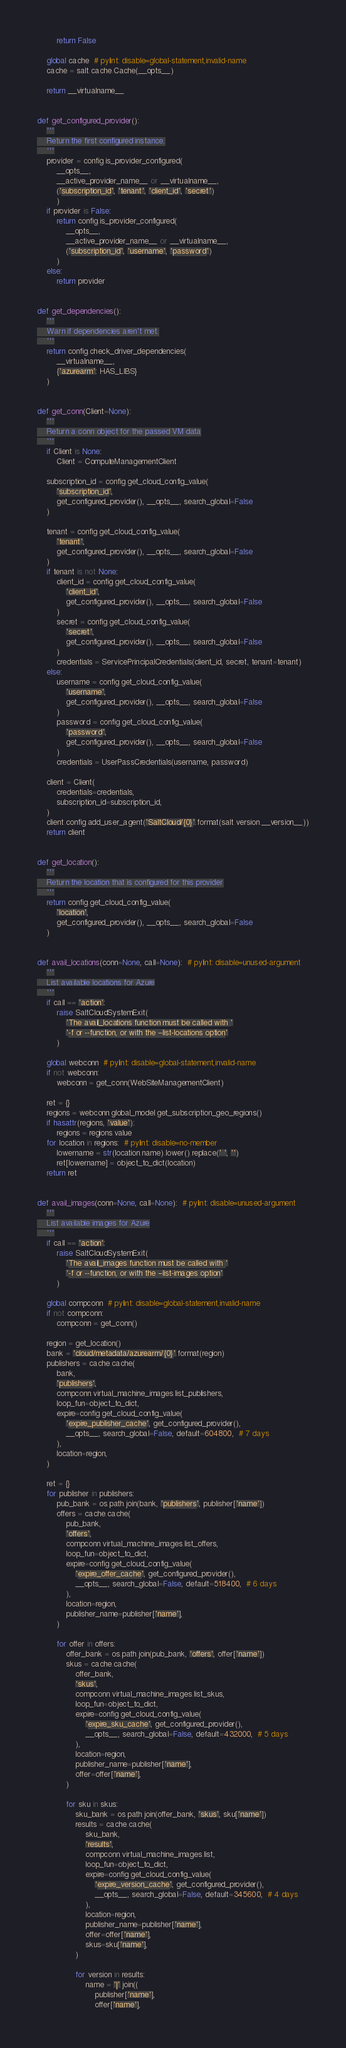Convert code to text. <code><loc_0><loc_0><loc_500><loc_500><_Python_>        return False

    global cache  # pylint: disable=global-statement,invalid-name
    cache = salt.cache.Cache(__opts__)

    return __virtualname__


def get_configured_provider():
    '''
    Return the first configured instance.
    '''
    provider = config.is_provider_configured(
        __opts__,
        __active_provider_name__ or __virtualname__,
        ('subscription_id', 'tenant', 'client_id', 'secret')
        )
    if provider is False:
        return config.is_provider_configured(
            __opts__,
            __active_provider_name__ or __virtualname__,
            ('subscription_id', 'username', 'password')
        )
    else:
        return provider


def get_dependencies():
    '''
    Warn if dependencies aren't met.
    '''
    return config.check_driver_dependencies(
        __virtualname__,
        {'azurearm': HAS_LIBS}
    )


def get_conn(Client=None):
    '''
    Return a conn object for the passed VM data
    '''
    if Client is None:
        Client = ComputeManagementClient

    subscription_id = config.get_cloud_config_value(
        'subscription_id',
        get_configured_provider(), __opts__, search_global=False
    )

    tenant = config.get_cloud_config_value(
        'tenant',
        get_configured_provider(), __opts__, search_global=False
    )
    if tenant is not None:
        client_id = config.get_cloud_config_value(
            'client_id',
            get_configured_provider(), __opts__, search_global=False
        )
        secret = config.get_cloud_config_value(
            'secret',
            get_configured_provider(), __opts__, search_global=False
        )
        credentials = ServicePrincipalCredentials(client_id, secret, tenant=tenant)
    else:
        username = config.get_cloud_config_value(
            'username',
            get_configured_provider(), __opts__, search_global=False
        )
        password = config.get_cloud_config_value(
            'password',
            get_configured_provider(), __opts__, search_global=False
        )
        credentials = UserPassCredentials(username, password)

    client = Client(
        credentials=credentials,
        subscription_id=subscription_id,
    )
    client.config.add_user_agent('SaltCloud/{0}'.format(salt.version.__version__))
    return client


def get_location():
    '''
    Return the location that is configured for this provider
    '''
    return config.get_cloud_config_value(
        'location',
        get_configured_provider(), __opts__, search_global=False
    )


def avail_locations(conn=None, call=None):  # pylint: disable=unused-argument
    '''
    List available locations for Azure
    '''
    if call == 'action':
        raise SaltCloudSystemExit(
            'The avail_locations function must be called with '
            '-f or --function, or with the --list-locations option'
        )

    global webconn  # pylint: disable=global-statement,invalid-name
    if not webconn:
        webconn = get_conn(WebSiteManagementClient)

    ret = {}
    regions = webconn.global_model.get_subscription_geo_regions()
    if hasattr(regions, 'value'):
        regions = regions.value
    for location in regions:  # pylint: disable=no-member
        lowername = str(location.name).lower().replace(' ', '')
        ret[lowername] = object_to_dict(location)
    return ret


def avail_images(conn=None, call=None):  # pylint: disable=unused-argument
    '''
    List available images for Azure
    '''
    if call == 'action':
        raise SaltCloudSystemExit(
            'The avail_images function must be called with '
            '-f or --function, or with the --list-images option'
        )

    global compconn  # pylint: disable=global-statement,invalid-name
    if not compconn:
        compconn = get_conn()

    region = get_location()
    bank = 'cloud/metadata/azurearm/{0}'.format(region)
    publishers = cache.cache(
        bank,
        'publishers',
        compconn.virtual_machine_images.list_publishers,
        loop_fun=object_to_dict,
        expire=config.get_cloud_config_value(
            'expire_publisher_cache', get_configured_provider(),
            __opts__, search_global=False, default=604800,  # 7 days
        ),
        location=region,
    )

    ret = {}
    for publisher in publishers:
        pub_bank = os.path.join(bank, 'publishers', publisher['name'])
        offers = cache.cache(
            pub_bank,
            'offers',
            compconn.virtual_machine_images.list_offers,
            loop_fun=object_to_dict,
            expire=config.get_cloud_config_value(
                'expire_offer_cache', get_configured_provider(),
                __opts__, search_global=False, default=518400,  # 6 days
            ),
            location=region,
            publisher_name=publisher['name'],
        )

        for offer in offers:
            offer_bank = os.path.join(pub_bank, 'offers', offer['name'])
            skus = cache.cache(
                offer_bank,
                'skus',
                compconn.virtual_machine_images.list_skus,
                loop_fun=object_to_dict,
                expire=config.get_cloud_config_value(
                    'expire_sku_cache', get_configured_provider(),
                    __opts__, search_global=False, default=432000,  # 5 days
                ),
                location=region,
                publisher_name=publisher['name'],
                offer=offer['name'],
            )

            for sku in skus:
                sku_bank = os.path.join(offer_bank, 'skus', sku['name'])
                results = cache.cache(
                    sku_bank,
                    'results',
                    compconn.virtual_machine_images.list,
                    loop_fun=object_to_dict,
                    expire=config.get_cloud_config_value(
                        'expire_version_cache', get_configured_provider(),
                        __opts__, search_global=False, default=345600,  # 4 days
                    ),
                    location=region,
                    publisher_name=publisher['name'],
                    offer=offer['name'],
                    skus=sku['name'],
                )

                for version in results:
                    name = '|'.join((
                        publisher['name'],
                        offer['name'],</code> 